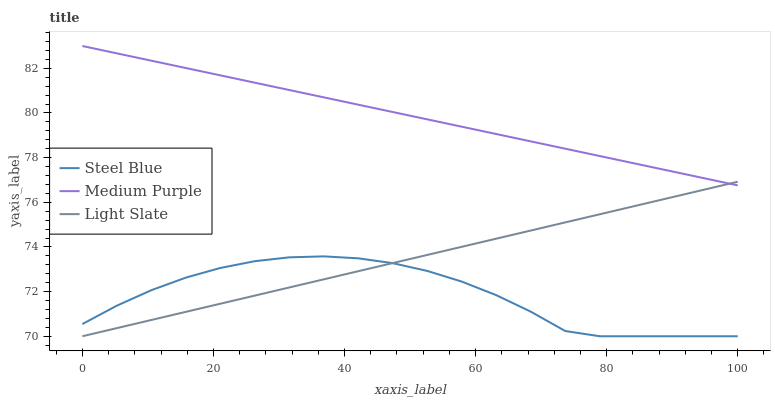Does Steel Blue have the minimum area under the curve?
Answer yes or no. Yes. Does Medium Purple have the maximum area under the curve?
Answer yes or no. Yes. Does Light Slate have the minimum area under the curve?
Answer yes or no. No. Does Light Slate have the maximum area under the curve?
Answer yes or no. No. Is Medium Purple the smoothest?
Answer yes or no. Yes. Is Steel Blue the roughest?
Answer yes or no. Yes. Is Light Slate the smoothest?
Answer yes or no. No. Is Light Slate the roughest?
Answer yes or no. No. Does Light Slate have the lowest value?
Answer yes or no. Yes. Does Medium Purple have the highest value?
Answer yes or no. Yes. Does Light Slate have the highest value?
Answer yes or no. No. Is Steel Blue less than Medium Purple?
Answer yes or no. Yes. Is Medium Purple greater than Steel Blue?
Answer yes or no. Yes. Does Medium Purple intersect Light Slate?
Answer yes or no. Yes. Is Medium Purple less than Light Slate?
Answer yes or no. No. Is Medium Purple greater than Light Slate?
Answer yes or no. No. Does Steel Blue intersect Medium Purple?
Answer yes or no. No. 